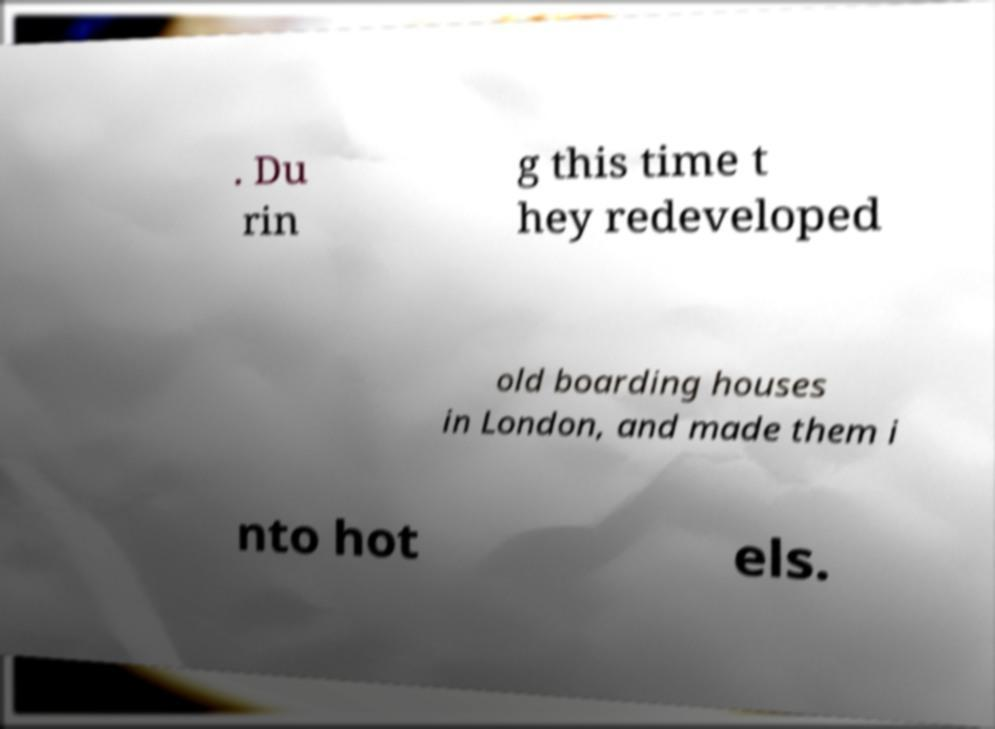Could you assist in decoding the text presented in this image and type it out clearly? . Du rin g this time t hey redeveloped old boarding houses in London, and made them i nto hot els. 